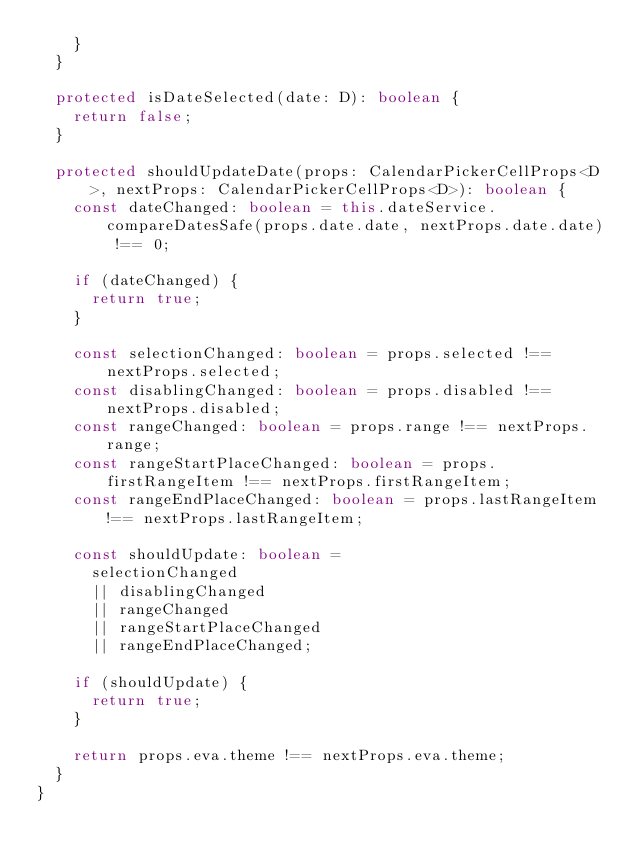<code> <loc_0><loc_0><loc_500><loc_500><_TypeScript_>    }
  }

  protected isDateSelected(date: D): boolean {
    return false;
  }

  protected shouldUpdateDate(props: CalendarPickerCellProps<D>, nextProps: CalendarPickerCellProps<D>): boolean {
    const dateChanged: boolean = this.dateService.compareDatesSafe(props.date.date, nextProps.date.date) !== 0;

    if (dateChanged) {
      return true;
    }

    const selectionChanged: boolean = props.selected !== nextProps.selected;
    const disablingChanged: boolean = props.disabled !== nextProps.disabled;
    const rangeChanged: boolean = props.range !== nextProps.range;
    const rangeStartPlaceChanged: boolean = props.firstRangeItem !== nextProps.firstRangeItem;
    const rangeEndPlaceChanged: boolean = props.lastRangeItem !== nextProps.lastRangeItem;

    const shouldUpdate: boolean =
      selectionChanged
      || disablingChanged
      || rangeChanged
      || rangeStartPlaceChanged
      || rangeEndPlaceChanged;

    if (shouldUpdate) {
      return true;
    }

    return props.eva.theme !== nextProps.eva.theme;
  }
}
</code> 